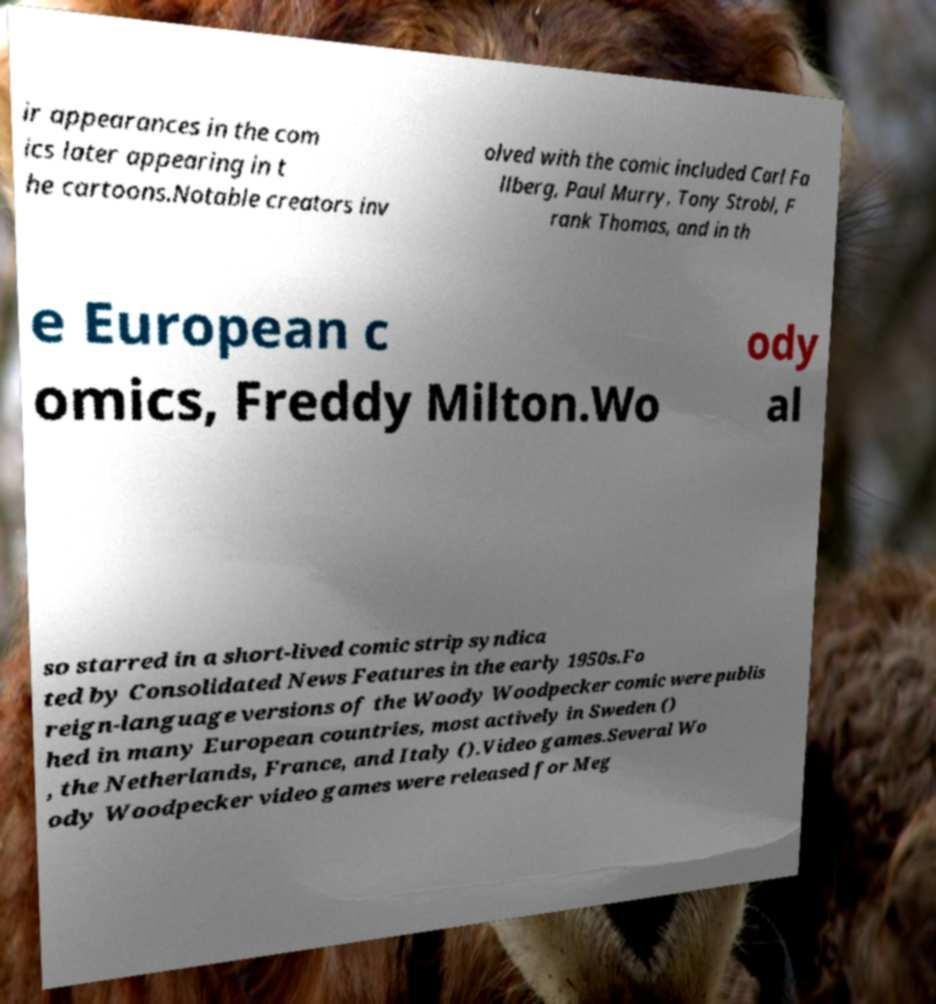There's text embedded in this image that I need extracted. Can you transcribe it verbatim? ir appearances in the com ics later appearing in t he cartoons.Notable creators inv olved with the comic included Carl Fa llberg, Paul Murry, Tony Strobl, F rank Thomas, and in th e European c omics, Freddy Milton.Wo ody al so starred in a short-lived comic strip syndica ted by Consolidated News Features in the early 1950s.Fo reign-language versions of the Woody Woodpecker comic were publis hed in many European countries, most actively in Sweden () , the Netherlands, France, and Italy ().Video games.Several Wo ody Woodpecker video games were released for Meg 